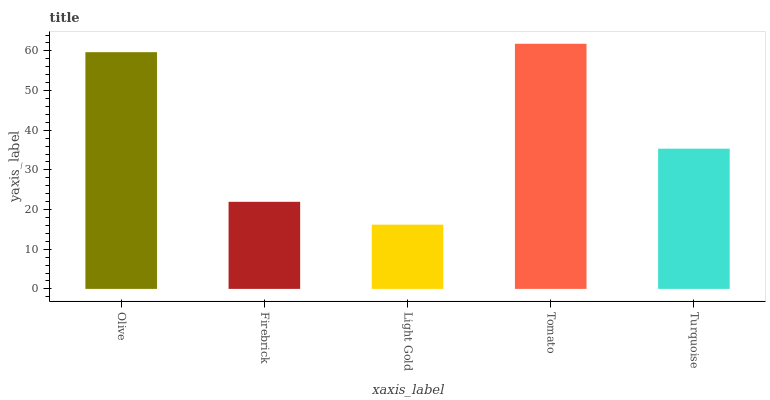Is Light Gold the minimum?
Answer yes or no. Yes. Is Tomato the maximum?
Answer yes or no. Yes. Is Firebrick the minimum?
Answer yes or no. No. Is Firebrick the maximum?
Answer yes or no. No. Is Olive greater than Firebrick?
Answer yes or no. Yes. Is Firebrick less than Olive?
Answer yes or no. Yes. Is Firebrick greater than Olive?
Answer yes or no. No. Is Olive less than Firebrick?
Answer yes or no. No. Is Turquoise the high median?
Answer yes or no. Yes. Is Turquoise the low median?
Answer yes or no. Yes. Is Tomato the high median?
Answer yes or no. No. Is Firebrick the low median?
Answer yes or no. No. 